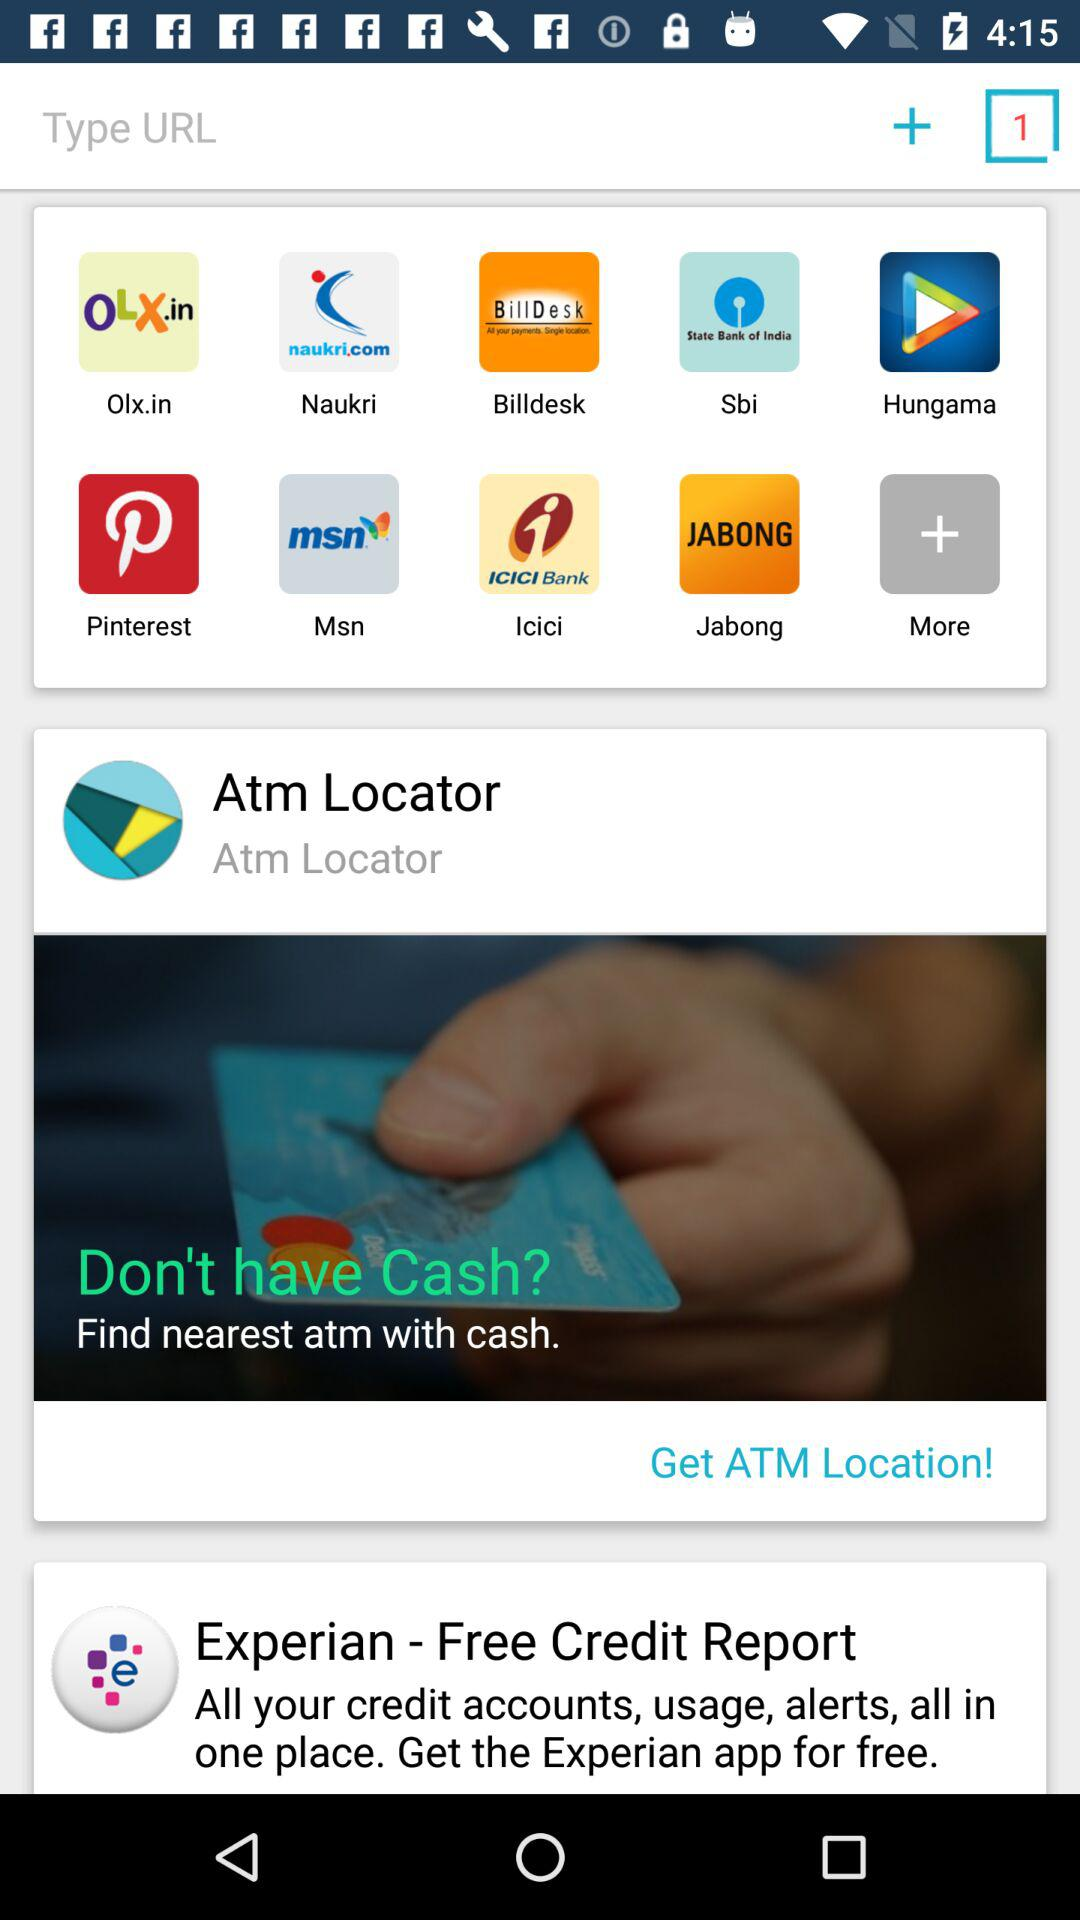Which app is used for the Free Credit Report?
When the provided information is insufficient, respond with <no answer>. <no answer> 